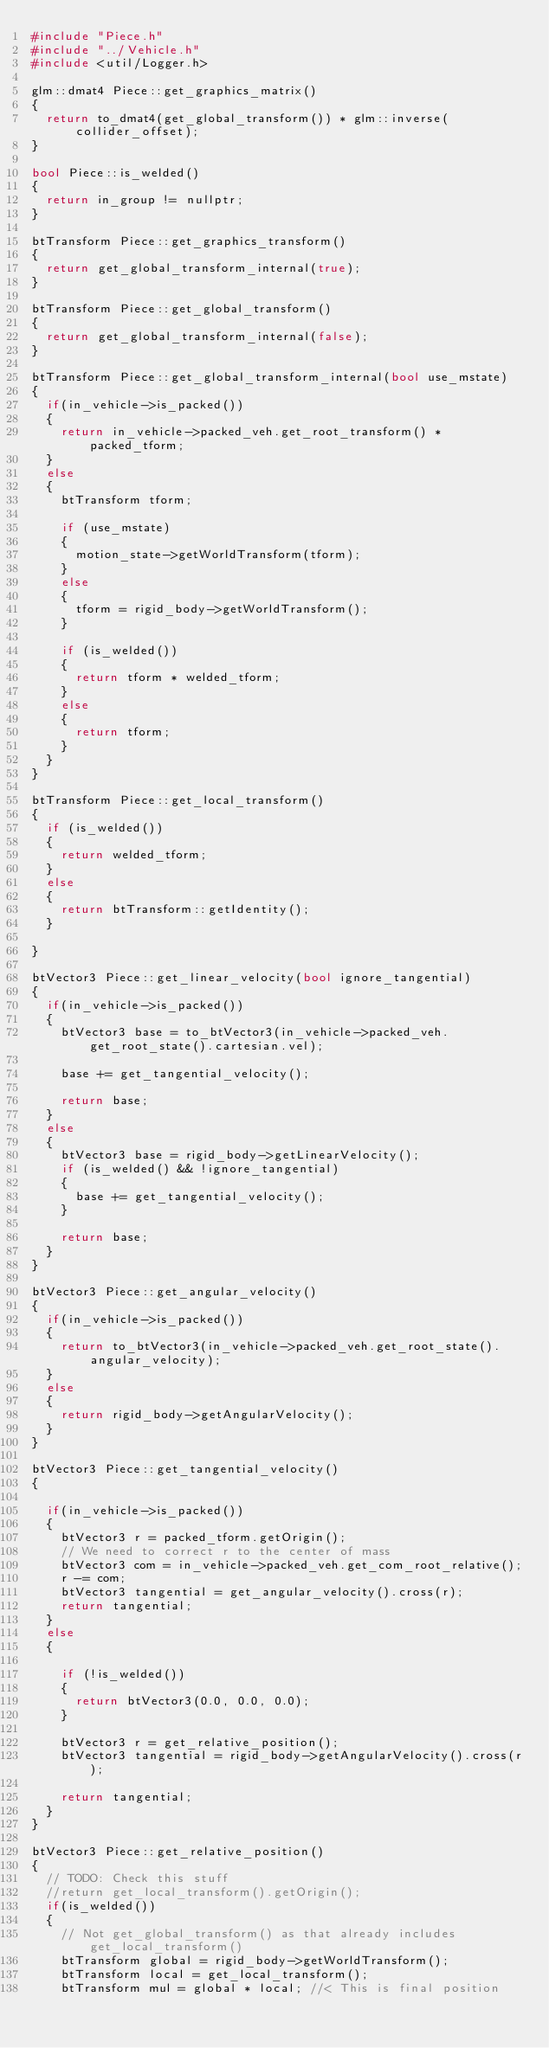Convert code to text. <code><loc_0><loc_0><loc_500><loc_500><_C++_>#include "Piece.h"
#include "../Vehicle.h"
#include <util/Logger.h>

glm::dmat4 Piece::get_graphics_matrix()
{
	return to_dmat4(get_global_transform()) * glm::inverse(collider_offset);
}

bool Piece::is_welded()
{
	return in_group != nullptr;
}

btTransform Piece::get_graphics_transform()
{
	return get_global_transform_internal(true);
}

btTransform Piece::get_global_transform()
{
	return get_global_transform_internal(false);
}

btTransform Piece::get_global_transform_internal(bool use_mstate)
{
	if(in_vehicle->is_packed())
	{
		return in_vehicle->packed_veh.get_root_transform() * packed_tform;
	}
	else 
	{
		btTransform tform;

		if (use_mstate)
		{
			motion_state->getWorldTransform(tform);
		}
		else
		{
			tform = rigid_body->getWorldTransform();
		}

		if (is_welded())
		{
			return tform * welded_tform;
		}
		else
		{
			return tform;
		}
	}
}

btTransform Piece::get_local_transform()
{
	if (is_welded())
	{
		return welded_tform;
	}
	else
	{
		return btTransform::getIdentity();
	}
	
}

btVector3 Piece::get_linear_velocity(bool ignore_tangential)
{
	if(in_vehicle->is_packed())
	{
		btVector3 base = to_btVector3(in_vehicle->packed_veh.get_root_state().cartesian.vel);
	
		base += get_tangential_velocity();

		return base;
	}
	else
	{
		btVector3 base = rigid_body->getLinearVelocity();
		if (is_welded() && !ignore_tangential)
		{
			base += get_tangential_velocity();
		}

		return base;
	}
}

btVector3 Piece::get_angular_velocity()
{
	if(in_vehicle->is_packed())
	{
		return to_btVector3(in_vehicle->packed_veh.get_root_state().angular_velocity);
	}
	else 
	{
		return rigid_body->getAngularVelocity();
	}
}

btVector3 Piece::get_tangential_velocity()
{

	if(in_vehicle->is_packed())
	{
		btVector3 r = packed_tform.getOrigin();
		// We need to correct r to the center of mass
		btVector3 com = in_vehicle->packed_veh.get_com_root_relative();
		r -= com;
		btVector3 tangential = get_angular_velocity().cross(r);
		return tangential;
	}
	else 
	{

		if (!is_welded())
		{
			return btVector3(0.0, 0.0, 0.0);
		}

		btVector3 r = get_relative_position();
		btVector3 tangential = rigid_body->getAngularVelocity().cross(r);
	
		return tangential;
	}
}

btVector3 Piece::get_relative_position()
{
	// TODO: Check this stuff
	//return get_local_transform().getOrigin();
	if(is_welded())
	{
		// Not get_global_transform() as that already includes get_local_transform()
		btTransform global = rigid_body->getWorldTransform();
		btTransform local = get_local_transform();
		btTransform mul = global * local; //< This is final position
</code> 